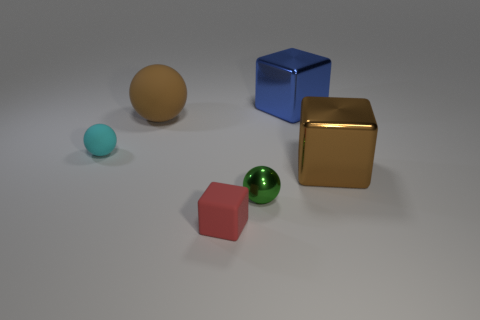Add 4 brown rubber balls. How many objects exist? 10 Subtract 0 yellow cubes. How many objects are left? 6 Subtract all small red rubber blocks. Subtract all small balls. How many objects are left? 3 Add 1 cyan matte objects. How many cyan matte objects are left? 2 Add 3 large gray shiny things. How many large gray shiny things exist? 3 